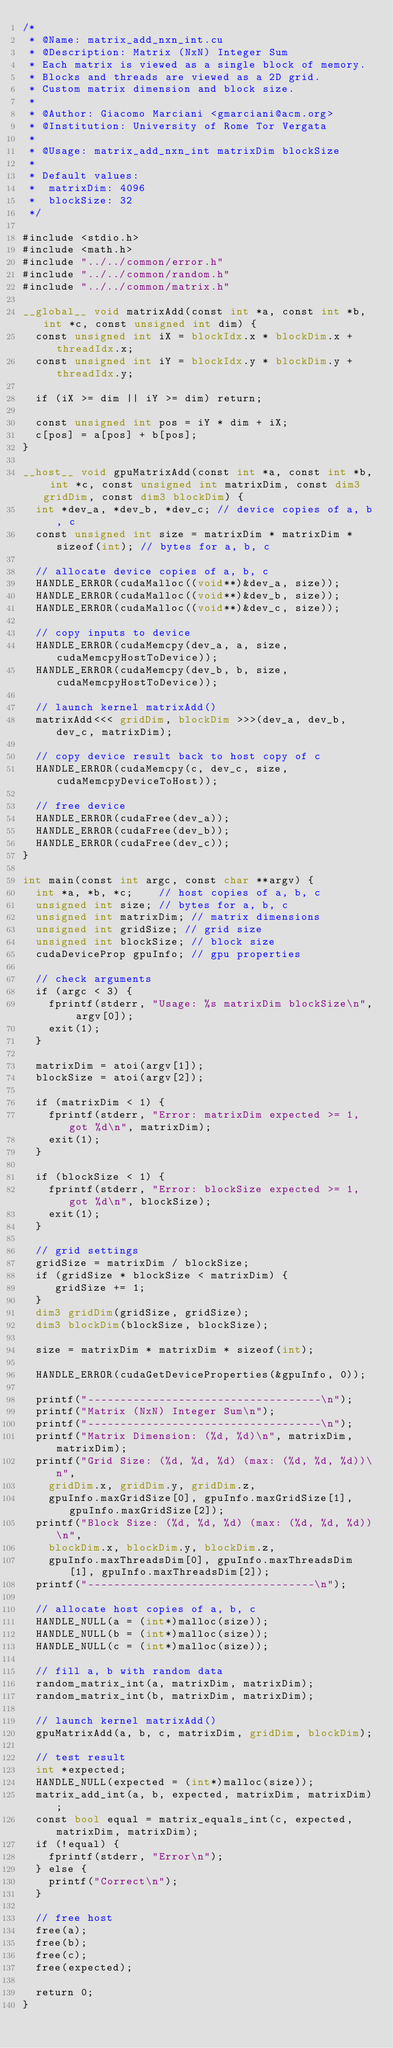<code> <loc_0><loc_0><loc_500><loc_500><_Cuda_>/*
 * @Name: matrix_add_nxn_int.cu
 * @Description: Matrix (NxN) Integer Sum
 * Each matrix is viewed as a single block of memory.
 * Blocks and threads are viewed as a 2D grid.
 * Custom matrix dimension and block size.
 *
 * @Author: Giacomo Marciani <gmarciani@acm.org>
 * @Institution: University of Rome Tor Vergata
 *
 * @Usage: matrix_add_nxn_int matrixDim blockSize
 *
 * Default values:
 *  matrixDim: 4096
 *  blockSize: 32
 */

#include <stdio.h>
#include <math.h>
#include "../../common/error.h"
#include "../../common/random.h"
#include "../../common/matrix.h"

__global__ void matrixAdd(const int *a, const int *b, int *c, const unsigned int dim) {
  const unsigned int iX = blockIdx.x * blockDim.x + threadIdx.x;
  const unsigned int iY = blockIdx.y * blockDim.y + threadIdx.y;

  if (iX >= dim || iY >= dim) return;

  const unsigned int pos = iY * dim + iX;
  c[pos] = a[pos] + b[pos];
}

__host__ void gpuMatrixAdd(const int *a, const int *b, int *c, const unsigned int matrixDim, const dim3 gridDim, const dim3 blockDim) {
  int *dev_a, *dev_b, *dev_c; // device copies of a, b, c
  const unsigned int size = matrixDim * matrixDim * sizeof(int); // bytes for a, b, c

  // allocate device copies of a, b, c
  HANDLE_ERROR(cudaMalloc((void**)&dev_a, size));
  HANDLE_ERROR(cudaMalloc((void**)&dev_b, size));
  HANDLE_ERROR(cudaMalloc((void**)&dev_c, size));

  // copy inputs to device
  HANDLE_ERROR(cudaMemcpy(dev_a, a, size, cudaMemcpyHostToDevice));
  HANDLE_ERROR(cudaMemcpy(dev_b, b, size, cudaMemcpyHostToDevice));

  // launch kernel matrixAdd()
  matrixAdd<<< gridDim, blockDim >>>(dev_a, dev_b, dev_c, matrixDim);

  // copy device result back to host copy of c
  HANDLE_ERROR(cudaMemcpy(c, dev_c, size, cudaMemcpyDeviceToHost));

  // free device
  HANDLE_ERROR(cudaFree(dev_a));
  HANDLE_ERROR(cudaFree(dev_b));
  HANDLE_ERROR(cudaFree(dev_c));
}

int main(const int argc, const char **argv) {
  int *a, *b, *c;    // host copies of a, b, c
  unsigned int size; // bytes for a, b, c
  unsigned int matrixDim; // matrix dimensions
  unsigned int gridSize; // grid size
  unsigned int blockSize; // block size
  cudaDeviceProp gpuInfo; // gpu properties

  // check arguments
  if (argc < 3) {
    fprintf(stderr, "Usage: %s matrixDim blockSize\n", argv[0]);
    exit(1);
  }

  matrixDim = atoi(argv[1]);
  blockSize = atoi(argv[2]);

  if (matrixDim < 1) {
    fprintf(stderr, "Error: matrixDim expected >= 1, got %d\n", matrixDim);
    exit(1);
  }

  if (blockSize < 1) {
    fprintf(stderr, "Error: blockSize expected >= 1, got %d\n", blockSize);
    exit(1);
  }

  // grid settings
  gridSize = matrixDim / blockSize;
  if (gridSize * blockSize < matrixDim) {
     gridSize += 1;
  }
  dim3 gridDim(gridSize, gridSize);
  dim3 blockDim(blockSize, blockSize);

  size = matrixDim * matrixDim * sizeof(int);

  HANDLE_ERROR(cudaGetDeviceProperties(&gpuInfo, 0));

  printf("------------------------------------\n");
  printf("Matrix (NxN) Integer Sum\n");
  printf("------------------------------------\n");
  printf("Matrix Dimension: (%d, %d)\n", matrixDim, matrixDim);
  printf("Grid Size: (%d, %d, %d) (max: (%d, %d, %d))\n",
    gridDim.x, gridDim.y, gridDim.z,
    gpuInfo.maxGridSize[0], gpuInfo.maxGridSize[1], gpuInfo.maxGridSize[2]);
  printf("Block Size: (%d, %d, %d) (max: (%d, %d, %d))\n",
    blockDim.x, blockDim.y, blockDim.z,
    gpuInfo.maxThreadsDim[0], gpuInfo.maxThreadsDim[1], gpuInfo.maxThreadsDim[2]);
  printf("-----------------------------------\n");

  // allocate host copies of a, b, c
  HANDLE_NULL(a = (int*)malloc(size));
  HANDLE_NULL(b = (int*)malloc(size));
  HANDLE_NULL(c = (int*)malloc(size));

  // fill a, b with random data
  random_matrix_int(a, matrixDim, matrixDim);
  random_matrix_int(b, matrixDim, matrixDim);

  // launch kernel matrixAdd()
  gpuMatrixAdd(a, b, c, matrixDim, gridDim, blockDim);

  // test result
  int *expected;
  HANDLE_NULL(expected = (int*)malloc(size));
  matrix_add_int(a, b, expected, matrixDim, matrixDim);
  const bool equal = matrix_equals_int(c, expected, matrixDim, matrixDim);
  if (!equal) {
    fprintf(stderr, "Error\n");
  } else {
    printf("Correct\n");
  }

  // free host
  free(a);
  free(b);
  free(c);
  free(expected);

  return 0;
}
</code> 